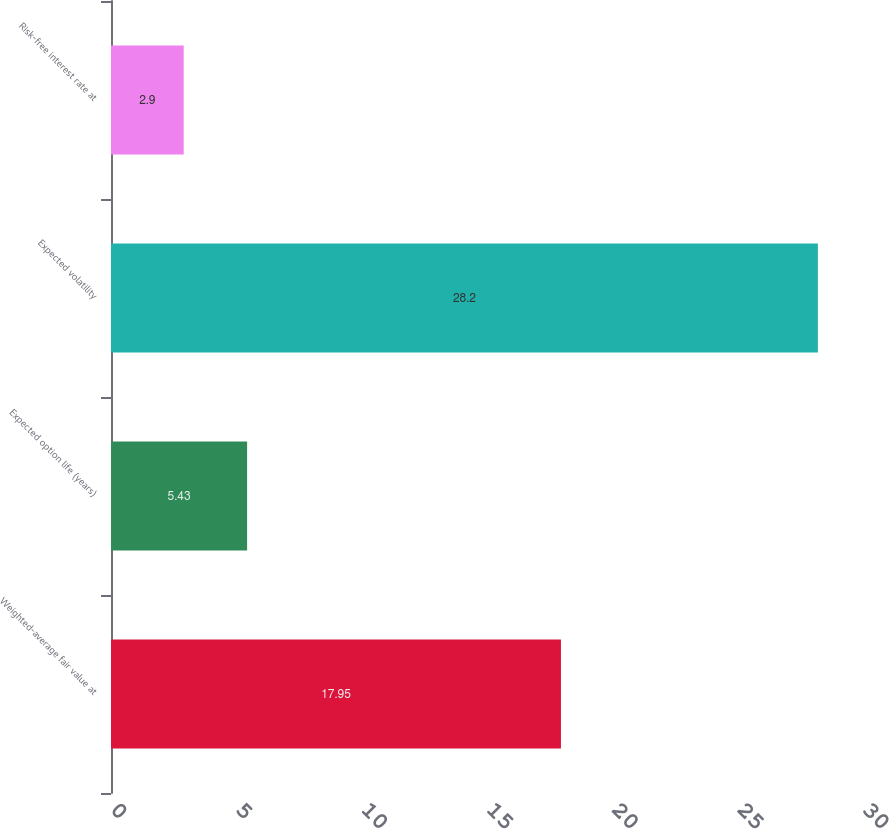Convert chart. <chart><loc_0><loc_0><loc_500><loc_500><bar_chart><fcel>Weighted-average fair value at<fcel>Expected option life (years)<fcel>Expected volatility<fcel>Risk-free interest rate at<nl><fcel>17.95<fcel>5.43<fcel>28.2<fcel>2.9<nl></chart> 